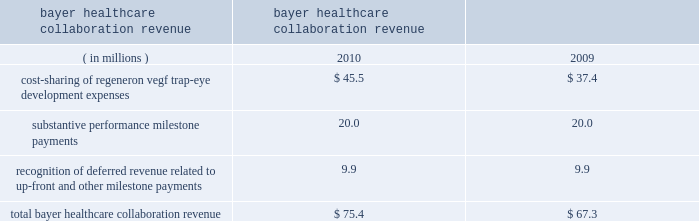Recognition of deferred revenue related to sanofi-aventis 2019 $ 85.0 million up-front payment decreased in 2010 compared to 2009 due to the november 2009 amendments to expand and extend the companies 2019 antibody collaboration .
In connection with the november 2009 amendment of the discovery agreement , sanofi-aventis is funding up to $ 30 million of agreed-upon costs incurred by us to expand our manufacturing capacity at our rensselaer , new york facilities , of which $ 23.4 million was received or receivable from sanofi-aventis as of december 31 , 2010 .
Revenue related to these payments for such funding from sanofi-aventis is deferred and recognized as collaboration revenue prospectively over the related performance period in conjunction with the recognition of the original $ 85.0 million up-front payment .
As of december 31 , 2010 , $ 79.8 million of the sanofi-aventis payments was deferred and will be recognized as revenue in future periods .
In august 2008 , we entered into a separate velocigene ae agreement with sanofi-aventis .
In 2010 and 2009 , we recognized $ 1.6 million and $ 2.7 million , respectively , in revenue related to this agreement .
Bayer healthcare collaboration revenue the collaboration revenue we earned from bayer healthcare , as detailed below , consisted of cost sharing of regeneron vegf trap-eye development expenses , substantive performance milestone payments , and recognition of revenue related to a non-refundable $ 75.0 million up-front payment received in october 2006 and a $ 20.0 million milestone payment received in august 2007 ( which , for the purpose of revenue recognition , was not considered substantive ) .
Years ended bayer healthcare collaboration revenue december 31 .
Cost-sharing of our vegf trap-eye development expenses with bayer healthcare increased in 2010 compared to 2009 due to higher internal development activities and higher clinical development costs in connection with our phase 3 copernicus trial in crvo .
In the fourth quarter of 2010 , we earned two $ 10.0 million substantive milestone payments from bayer healthcare for achieving positive 52-week results in the view 1 study and positive 6-month results in the copernicus study .
In july 2009 , we earned a $ 20.0 million substantive performance milestone payment from bayer healthcare in connection with the dosing of the first patient in the copernicus study .
In connection with the recognition of deferred revenue related to the $ 75.0 million up-front payment and $ 20.0 million milestone payment received in august 2007 , as of december 31 , 2010 , $ 47.0 million of these payments was deferred and will be recognized as revenue in future periods .
Technology licensing revenue in connection with our velocimmune ae license agreements with astrazeneca and astellas , each of the $ 20.0 million annual , non-refundable payments were deferred upon receipt and recognized as revenue ratably over approximately the ensuing year of each agreement .
In both 2010 and 2009 , we recognized $ 40.0 million of technology licensing revenue related to these agreements .
In addition , in connection with the amendment and extension of our license agreement with astellas , in august 2010 , we received a $ 165.0 million up-front payment , which was deferred upon receipt and will be recognized as revenue ratably over a seven-year period beginning in mid-2011 .
As of december 31 , 2010 , $ 176.6 million of these technology licensing payments was deferred and will be recognized as revenue in future periods .
Net product sales in 2010 and 2009 , we recognized as revenue $ 25.3 million and $ 18.4 million , respectively , of arcalyst ae net product sales for which both the right of return no longer existed and rebates could be reasonably estimated .
The company had limited historical return experience for arcalyst ae beginning with initial sales in 2008 through the end of 2009 ; therefore , arcalyst ae net product sales were deferred until the right of return no longer existed and rebates could be reasonably estimated .
Effective in the first quarter of 2010 , the company determined that it had .
What was the percentage change of total bayer healthcare collaboration revenue from 2009 to 2010? 
Computations: ((75.4 - 67.3) / 67.3)
Answer: 0.12036. 